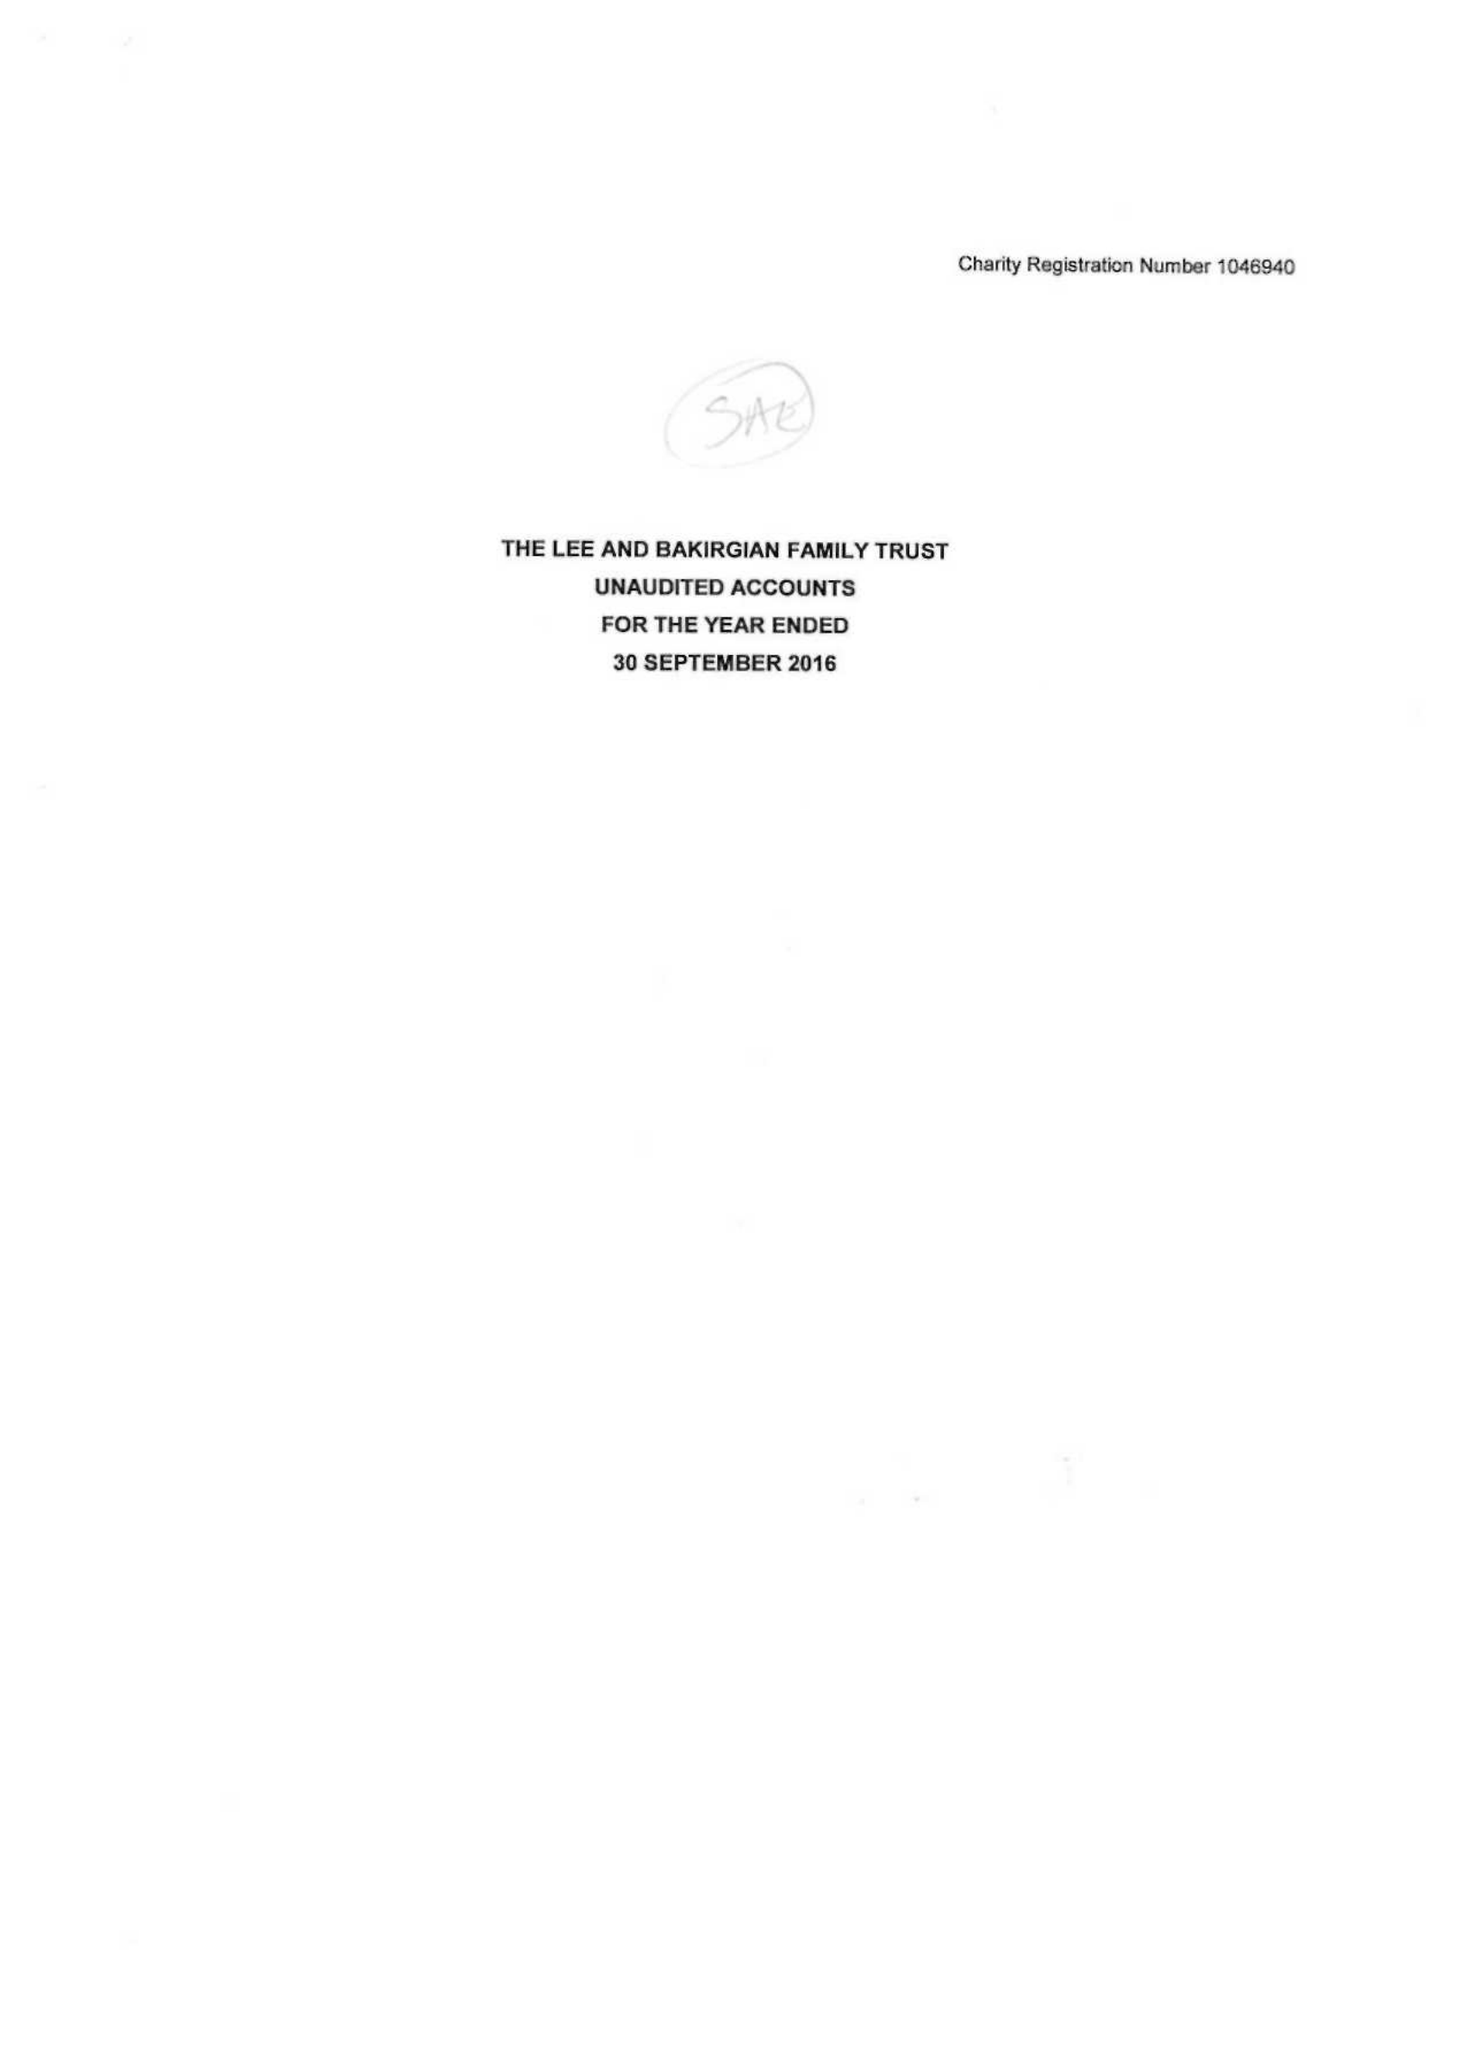What is the value for the income_annually_in_british_pounds?
Answer the question using a single word or phrase. 30236.00 